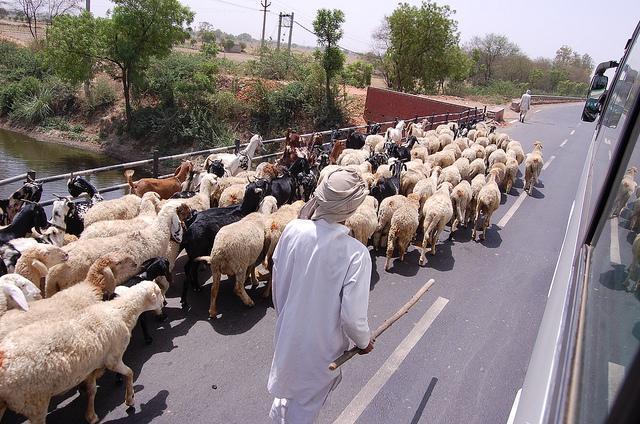What side of the rest is usually best for passing?
From the following set of four choices, select the accurate answer to respond to the question.
Options: Under, right, left, over. Left. 